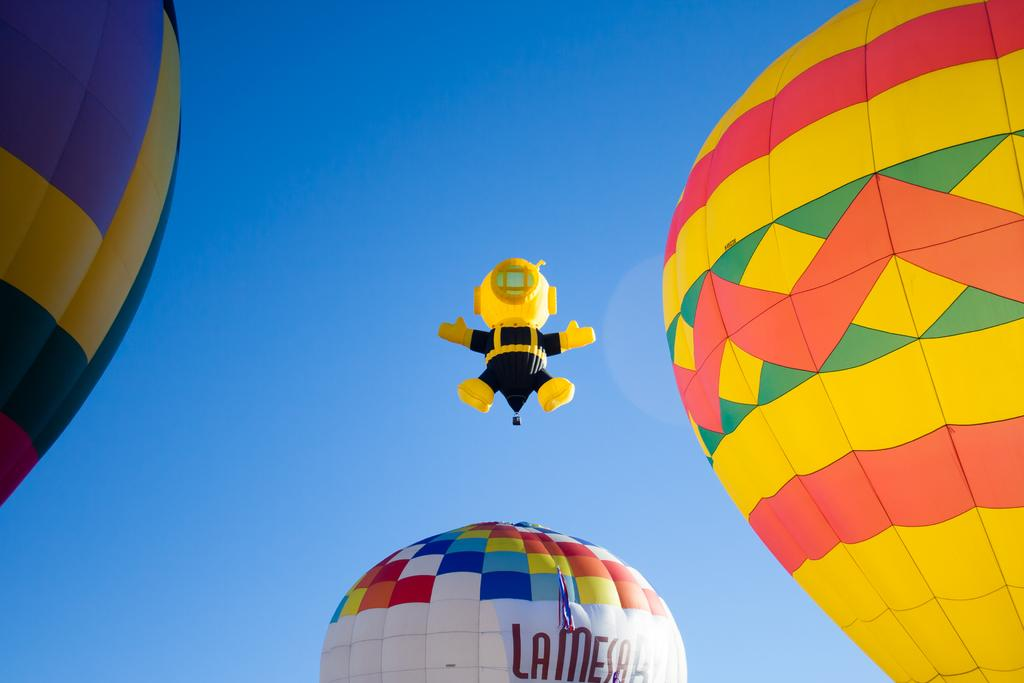<image>
Summarize the visual content of the image. three hot air balloons with a white one labeled la mesa 